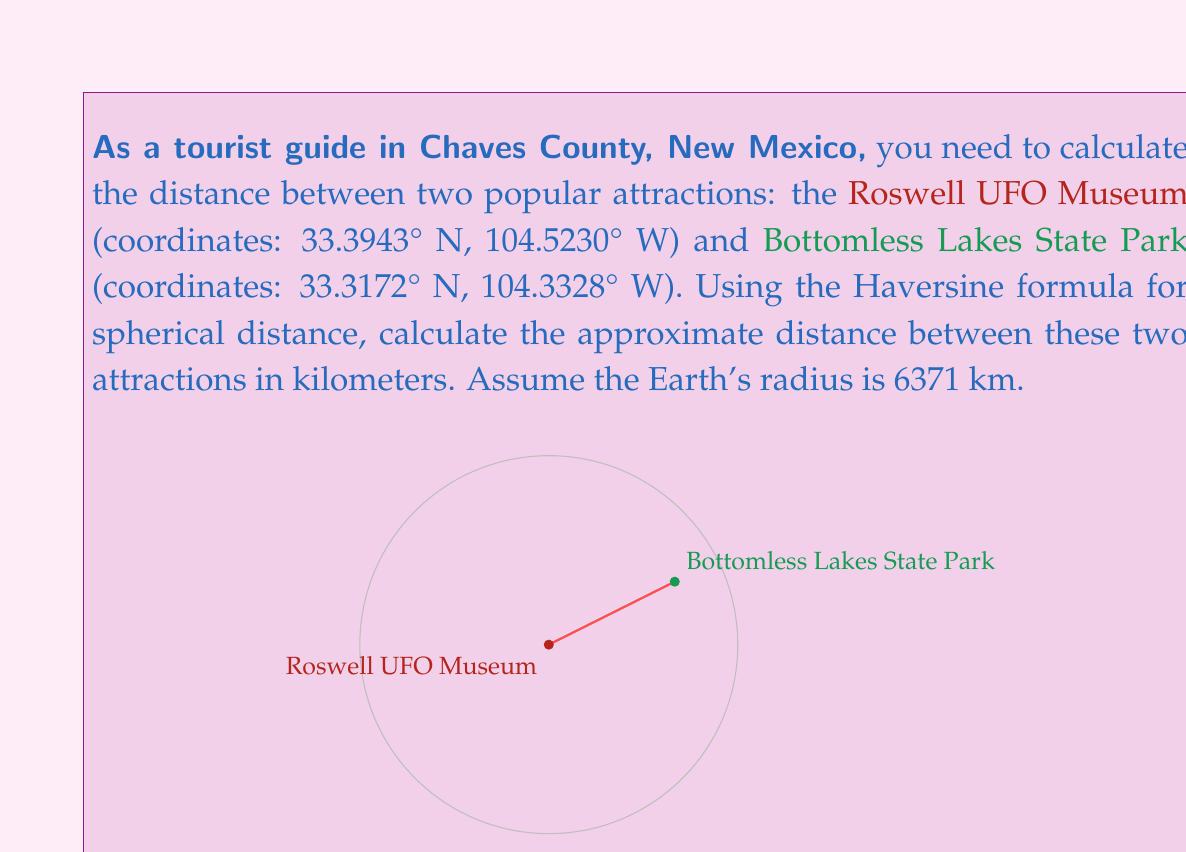Can you solve this math problem? To calculate the distance between two points on Earth using their latitude and longitude coordinates, we can use the Haversine formula. This formula takes into account the Earth's curvature.

Step 1: Convert the coordinates from degrees to radians.
$$\begin{align*}
\text{lat}_1 &= 33.3943° \cdot \frac{\pi}{180} = 0.5828 \text{ rad} \\
\text{lon}_1 &= -104.5230° \cdot \frac{\pi}{180} = -1.8244 \text{ rad} \\
\text{lat}_2 &= 33.3172° \cdot \frac{\pi}{180} = 0.5815 \text{ rad} \\
\text{lon}_2 &= -104.3328° \cdot \frac{\pi}{180} = -1.8211 \text{ rad}
\end{align*}$$

Step 2: Calculate the differences in latitude and longitude.
$$\begin{align*}
\Delta\text{lat} &= \text{lat}_2 - \text{lat}_1 = 0.5815 - 0.5828 = -0.0013 \text{ rad} \\
\Delta\text{lon} &= \text{lon}_2 - \text{lon}_1 = -1.8211 - (-1.8244) = 0.0033 \text{ rad}
\end{align*}$$

Step 3: Apply the Haversine formula.
$$a = \sin^2(\frac{\Delta\text{lat}}{2}) + \cos(\text{lat}_1) \cdot \cos(\text{lat}_2) \cdot \sin^2(\frac{\Delta\text{lon}}{2})$$

$$a = \sin^2(-0.00065) + \cos(0.5828) \cdot \cos(0.5815) \cdot \sin^2(0.00165)$$

$$a = 4.2275 \times 10^{-7} + 0.8340 \cdot 0.8344 \cdot 2.7225 \times 10^{-6} = 2.2644 \times 10^{-6}$$

Step 4: Calculate the central angle.
$$c = 2 \cdot \arctan2(\sqrt{a}, \sqrt{1-a})$$

$$c = 2 \cdot \arctan2(\sqrt{2.2644 \times 10^{-6}}, \sqrt{1-2.2644 \times 10^{-6}}) = 0.003010$$

Step 5: Calculate the distance.
$$d = R \cdot c$$

Where $R$ is the Earth's radius (6371 km).

$$d = 6371 \cdot 0.003010 = 19.18 \text{ km}$$

Therefore, the approximate distance between the Roswell UFO Museum and Bottomless Lakes State Park is 19.18 km.
Answer: 19.18 km 